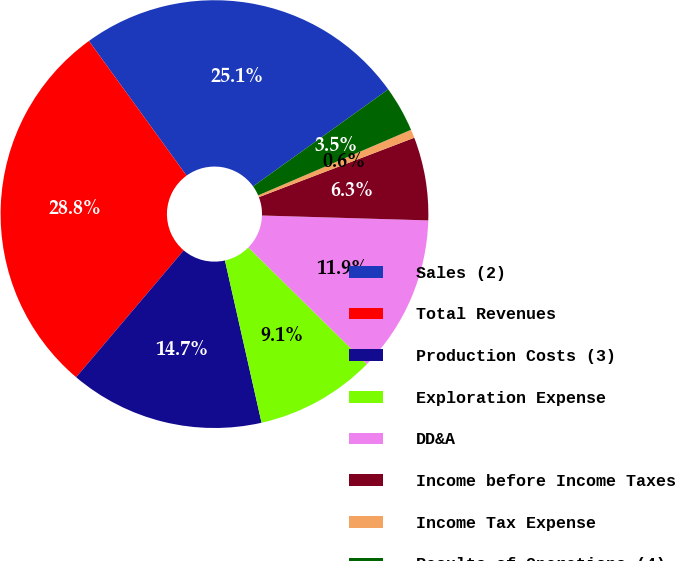Convert chart to OTSL. <chart><loc_0><loc_0><loc_500><loc_500><pie_chart><fcel>Sales (2)<fcel>Total Revenues<fcel>Production Costs (3)<fcel>Exploration Expense<fcel>DD&A<fcel>Income before Income Taxes<fcel>Income Tax Expense<fcel>Results of Operations (4)<nl><fcel>25.08%<fcel>28.82%<fcel>14.73%<fcel>9.09%<fcel>11.91%<fcel>6.28%<fcel>0.64%<fcel>3.46%<nl></chart> 